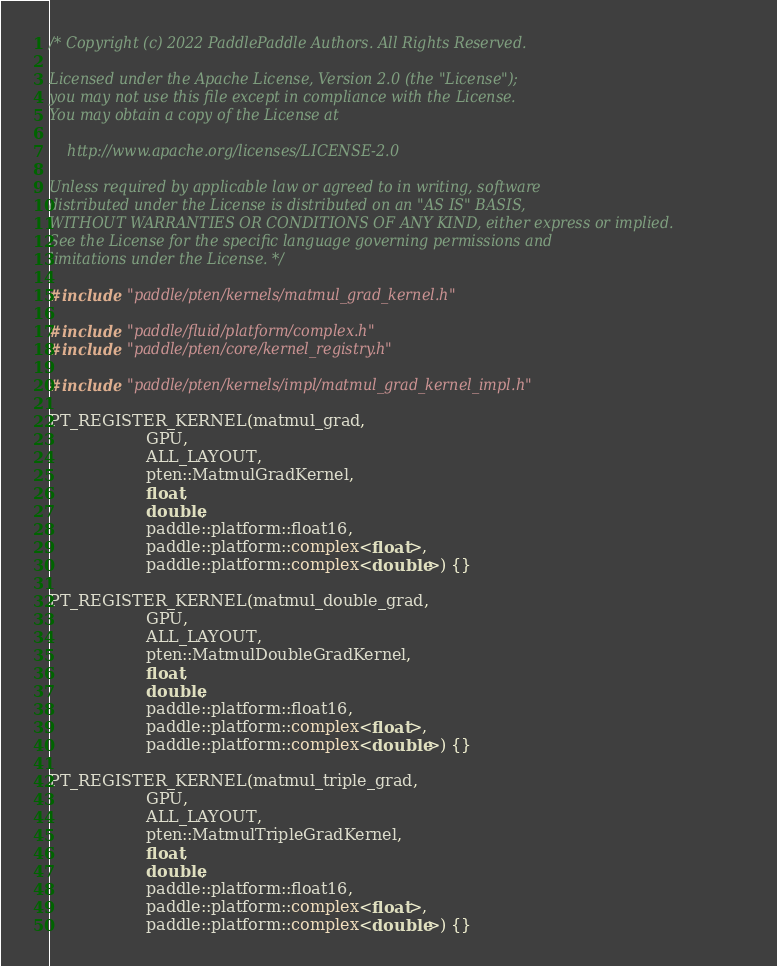Convert code to text. <code><loc_0><loc_0><loc_500><loc_500><_Cuda_>/* Copyright (c) 2022 PaddlePaddle Authors. All Rights Reserved.

Licensed under the Apache License, Version 2.0 (the "License");
you may not use this file except in compliance with the License.
You may obtain a copy of the License at

    http://www.apache.org/licenses/LICENSE-2.0

Unless required by applicable law or agreed to in writing, software
distributed under the License is distributed on an "AS IS" BASIS,
WITHOUT WARRANTIES OR CONDITIONS OF ANY KIND, either express or implied.
See the License for the specific language governing permissions and
limitations under the License. */

#include "paddle/pten/kernels/matmul_grad_kernel.h"

#include "paddle/fluid/platform/complex.h"
#include "paddle/pten/core/kernel_registry.h"

#include "paddle/pten/kernels/impl/matmul_grad_kernel_impl.h"

PT_REGISTER_KERNEL(matmul_grad,
                   GPU,
                   ALL_LAYOUT,
                   pten::MatmulGradKernel,
                   float,
                   double,
                   paddle::platform::float16,
                   paddle::platform::complex<float>,
                   paddle::platform::complex<double>) {}

PT_REGISTER_KERNEL(matmul_double_grad,
                   GPU,
                   ALL_LAYOUT,
                   pten::MatmulDoubleGradKernel,
                   float,
                   double,
                   paddle::platform::float16,
                   paddle::platform::complex<float>,
                   paddle::platform::complex<double>) {}

PT_REGISTER_KERNEL(matmul_triple_grad,
                   GPU,
                   ALL_LAYOUT,
                   pten::MatmulTripleGradKernel,
                   float,
                   double,
                   paddle::platform::float16,
                   paddle::platform::complex<float>,
                   paddle::platform::complex<double>) {}
</code> 